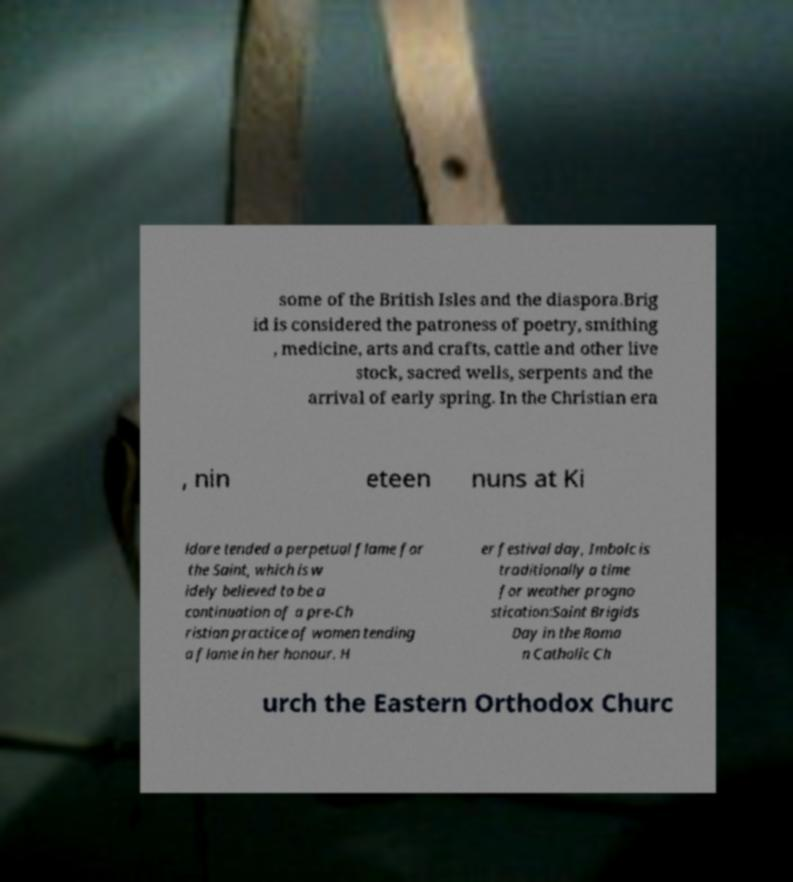There's text embedded in this image that I need extracted. Can you transcribe it verbatim? some of the British Isles and the diaspora.Brig id is considered the patroness of poetry, smithing , medicine, arts and crafts, cattle and other live stock, sacred wells, serpents and the arrival of early spring. In the Christian era , nin eteen nuns at Ki ldare tended a perpetual flame for the Saint, which is w idely believed to be a continuation of a pre-Ch ristian practice of women tending a flame in her honour. H er festival day, Imbolc is traditionally a time for weather progno stication:Saint Brigids Day in the Roma n Catholic Ch urch the Eastern Orthodox Churc 